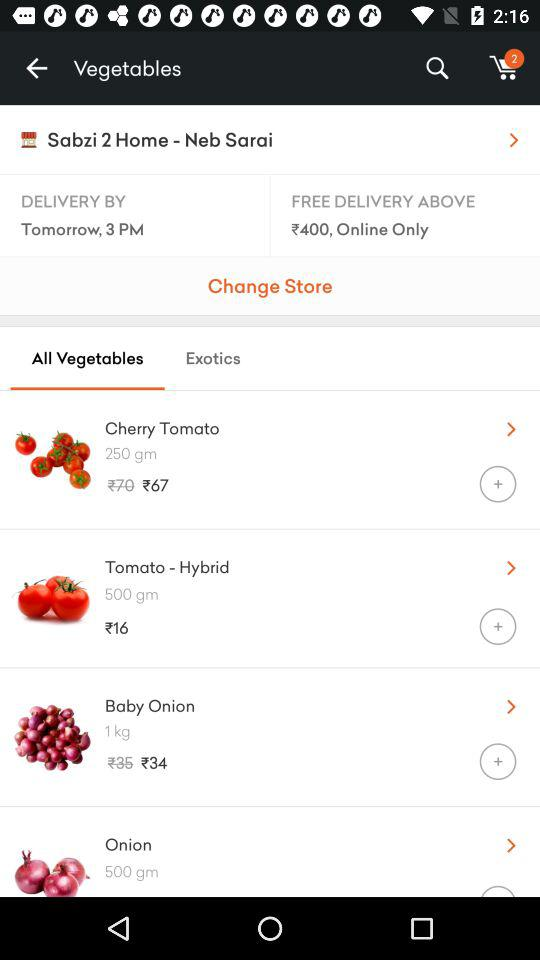How many items are in the cart? There are 2 items in the cart. 